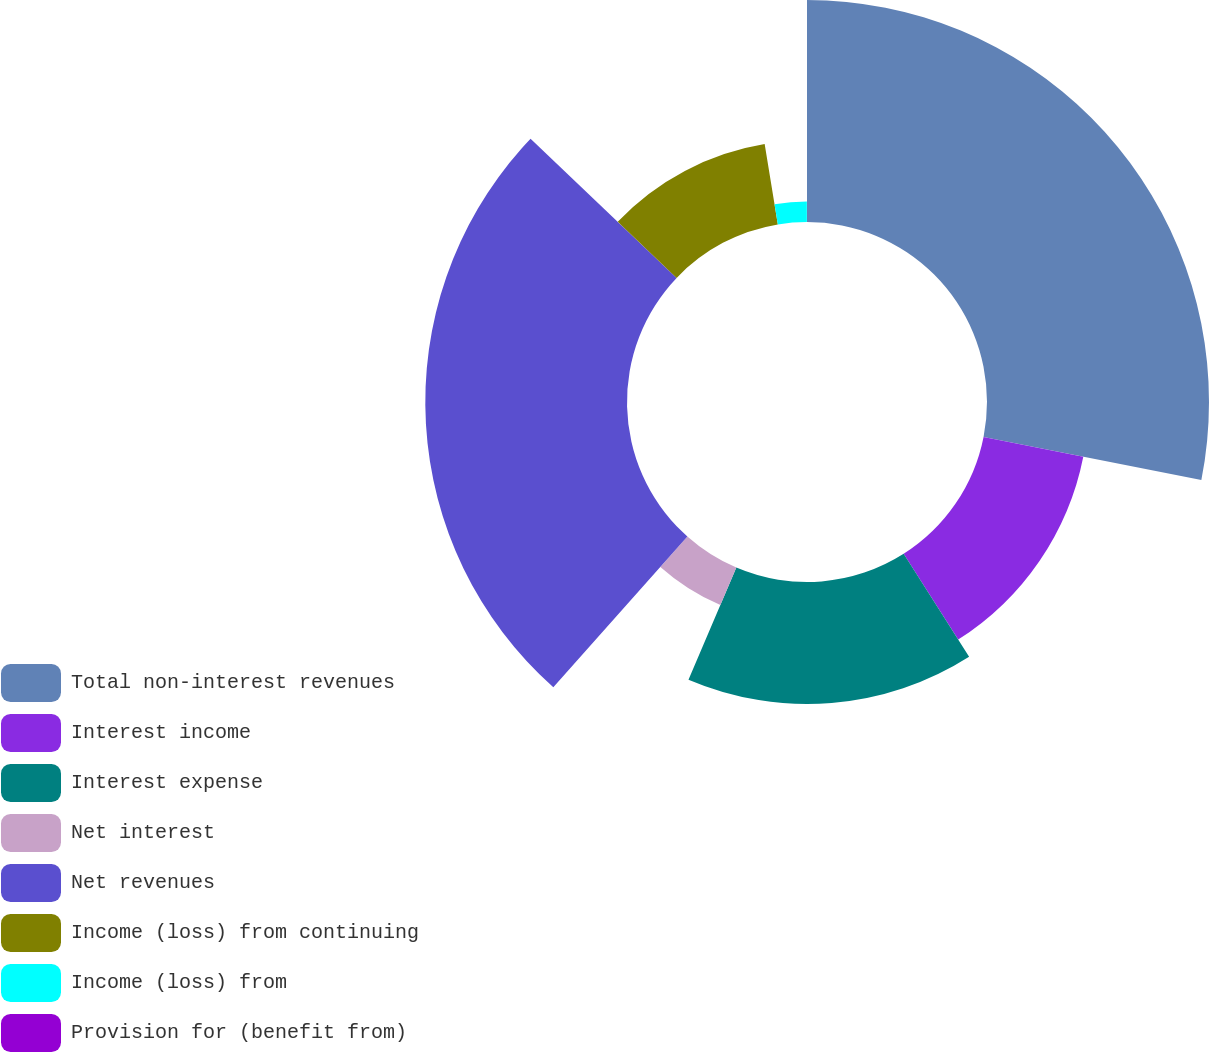Convert chart. <chart><loc_0><loc_0><loc_500><loc_500><pie_chart><fcel>Total non-interest revenues<fcel>Interest income<fcel>Interest expense<fcel>Net interest<fcel>Net revenues<fcel>Income (loss) from continuing<fcel>Income (loss) from<fcel>Provision for (benefit from)<nl><fcel>28.11%<fcel>12.87%<fcel>15.44%<fcel>5.15%<fcel>25.54%<fcel>10.3%<fcel>2.58%<fcel>0.01%<nl></chart> 